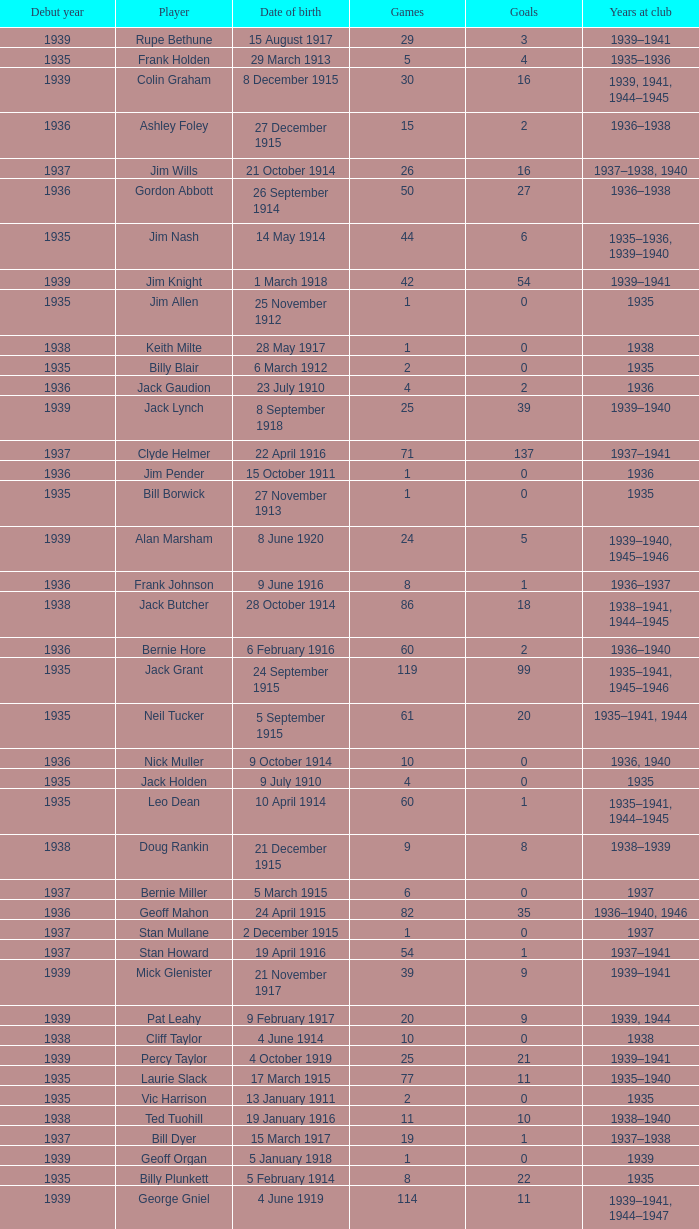What is the average games a player born on 17 March 1915 and debut before 1935 had? None. 